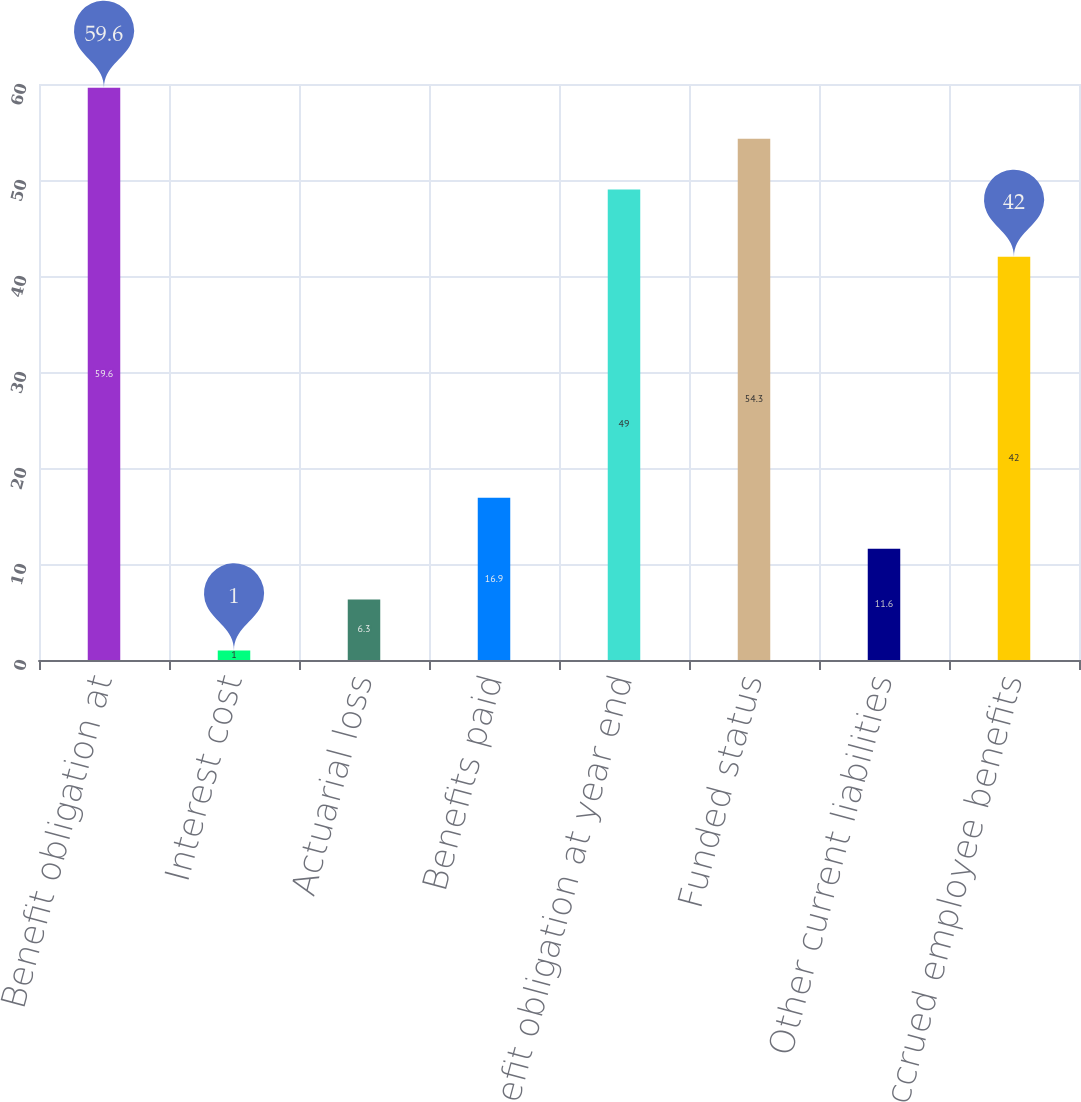Convert chart. <chart><loc_0><loc_0><loc_500><loc_500><bar_chart><fcel>Benefit obligation at<fcel>Interest cost<fcel>Actuarial loss<fcel>Benefits paid<fcel>Benefit obligation at year end<fcel>Funded status<fcel>Other current liabilities<fcel>Accrued employee benefits<nl><fcel>59.6<fcel>1<fcel>6.3<fcel>16.9<fcel>49<fcel>54.3<fcel>11.6<fcel>42<nl></chart> 